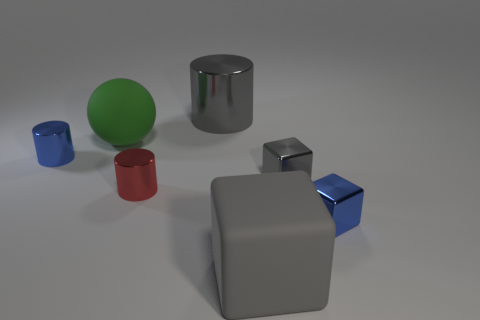Add 2 small gray metallic objects. How many objects exist? 9 Subtract all gray cylinders. How many cylinders are left? 2 Subtract all metal blocks. How many blocks are left? 1 Add 7 large things. How many large things exist? 10 Subtract 0 brown cylinders. How many objects are left? 7 Subtract all cylinders. How many objects are left? 4 Subtract 2 cylinders. How many cylinders are left? 1 Subtract all brown cylinders. Subtract all yellow cubes. How many cylinders are left? 3 Subtract all purple cubes. How many gray cylinders are left? 1 Subtract all tiny red metal things. Subtract all matte balls. How many objects are left? 5 